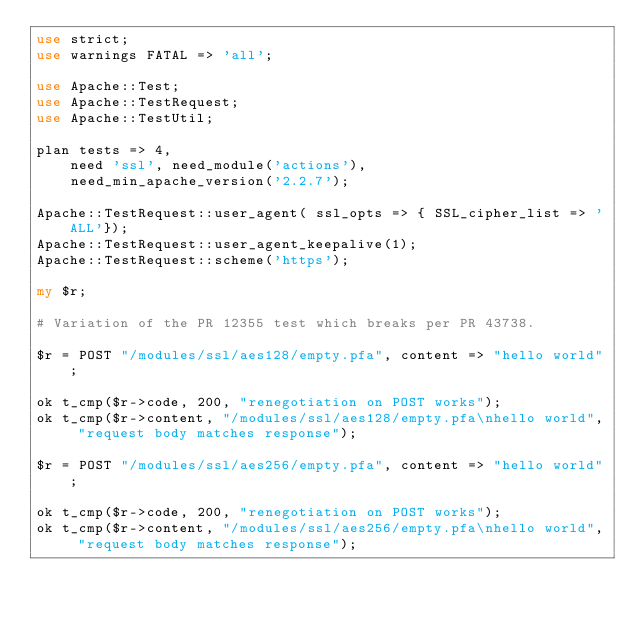Convert code to text. <code><loc_0><loc_0><loc_500><loc_500><_Perl_>use strict;
use warnings FATAL => 'all';

use Apache::Test;
use Apache::TestRequest;
use Apache::TestUtil;

plan tests => 4, 
    need 'ssl', need_module('actions'),
    need_min_apache_version('2.2.7');

Apache::TestRequest::user_agent( ssl_opts => { SSL_cipher_list => 'ALL'});
Apache::TestRequest::user_agent_keepalive(1);
Apache::TestRequest::scheme('https');

my $r;

# Variation of the PR 12355 test which breaks per PR 43738.

$r = POST "/modules/ssl/aes128/empty.pfa", content => "hello world";

ok t_cmp($r->code, 200, "renegotiation on POST works");
ok t_cmp($r->content, "/modules/ssl/aes128/empty.pfa\nhello world", "request body matches response");

$r = POST "/modules/ssl/aes256/empty.pfa", content => "hello world";

ok t_cmp($r->code, 200, "renegotiation on POST works");
ok t_cmp($r->content, "/modules/ssl/aes256/empty.pfa\nhello world", "request body matches response");
</code> 